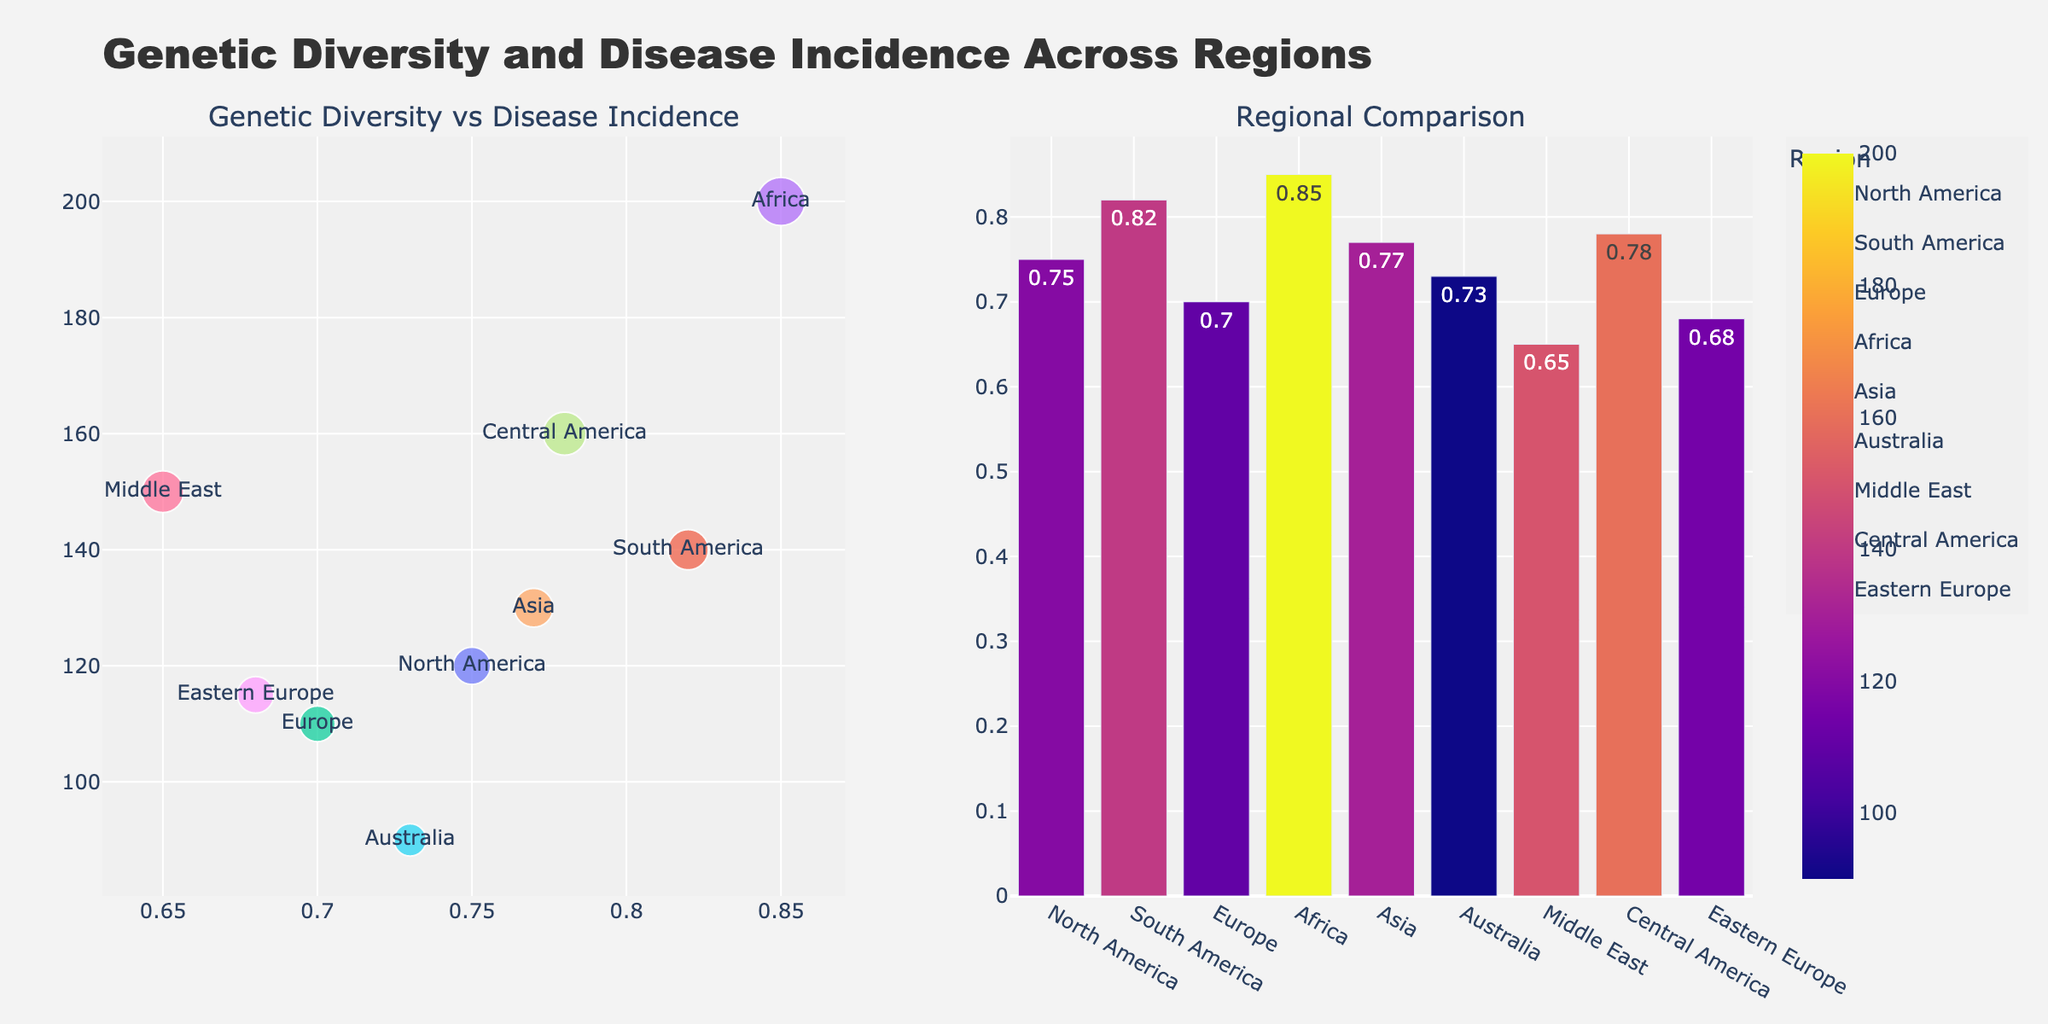what is the title of the figure? The title of the figure is usually located at the top. In this case, it says "Genetic Diversity and Disease Incidence Across Regions."
Answer: Genetic Diversity and Disease Incidence Across Regions Which region has the highest Genetic Diversity Index? By examining the bar plot on the right, we can see the region with the tallest bar on the y-axis labeled "Genetic Diversity Index". The region is Africa.
Answer: Africa What's the Disease Incidence Rate for Europe? We can find Europe on the scatter plot on the left. The y-axis shows Disease Incidence Rate. Europe is plotted with a y-value of 110.
Answer: 110 How many regions have Genetic Diversity Indexes greater than 0.75? By looking at the x-values on the bar plot, we identify the bars with x-values greater than 0.75. These regions are South America, Africa, Asia, and Central America. There are 4 such regions.
Answer: 4 Compare Genetic Diversity indices: Is the Genetic Diversity Index of Asia higher than that of North America? By comparing the bar heights on the right, Asia has a bar at around 0.77, and North America has a bar at around 0.75. Hence, Asia has a higher index.
Answer: Yes Which region has the lowest Disease Incidence Rate, and what is it? In the scatter plot on the left, identify the lowest y-value. The region 'Australia' has the lowest y-value, which is 90.
Answer: Australia, 90 Find the region with a Genetic Diversity Index of exactly 0.65. What is its Disease Incidence Rate? On the bar plot, locate the region with a bar at 0.65, which is the Middle East. Then, find its scatter plot point to determine its y-value, which is 150.
Answer: Middle East, 150 What are the regions with Disease Incidence Rates above 150? In the scatter plot, locate all points with y-values above 150. These regions are Africa and Central America.
Answer: Africa and Central America Which region has a higher Disease Incidence Rate: Eastern Europe or North America? In the scatter plot, compare the y-values for Eastern Europe (115) and North America (120). North America has a higher rate.
Answer: North America What is the average Genetic Diversity Index of all regions combined? Sum the Genetic Diversity Index values and divide by the number of regions: (0.75 + 0.82 + 0.7 + 0.85 + 0.77 + 0.73 + 0.65 + 0.78 + 0.68)/9 = 6.73/9 = 0.747.
Answer: 0.747 